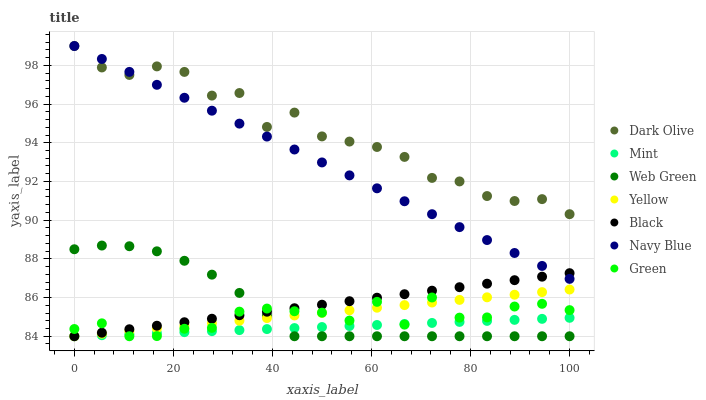Does Mint have the minimum area under the curve?
Answer yes or no. Yes. Does Dark Olive have the maximum area under the curve?
Answer yes or no. Yes. Does Yellow have the minimum area under the curve?
Answer yes or no. No. Does Yellow have the maximum area under the curve?
Answer yes or no. No. Is Yellow the smoothest?
Answer yes or no. Yes. Is Dark Olive the roughest?
Answer yes or no. Yes. Is Dark Olive the smoothest?
Answer yes or no. No. Is Yellow the roughest?
Answer yes or no. No. Does Yellow have the lowest value?
Answer yes or no. Yes. Does Dark Olive have the lowest value?
Answer yes or no. No. Does Dark Olive have the highest value?
Answer yes or no. Yes. Does Yellow have the highest value?
Answer yes or no. No. Is Mint less than Navy Blue?
Answer yes or no. Yes. Is Navy Blue greater than Yellow?
Answer yes or no. Yes. Does Web Green intersect Yellow?
Answer yes or no. Yes. Is Web Green less than Yellow?
Answer yes or no. No. Is Web Green greater than Yellow?
Answer yes or no. No. Does Mint intersect Navy Blue?
Answer yes or no. No. 